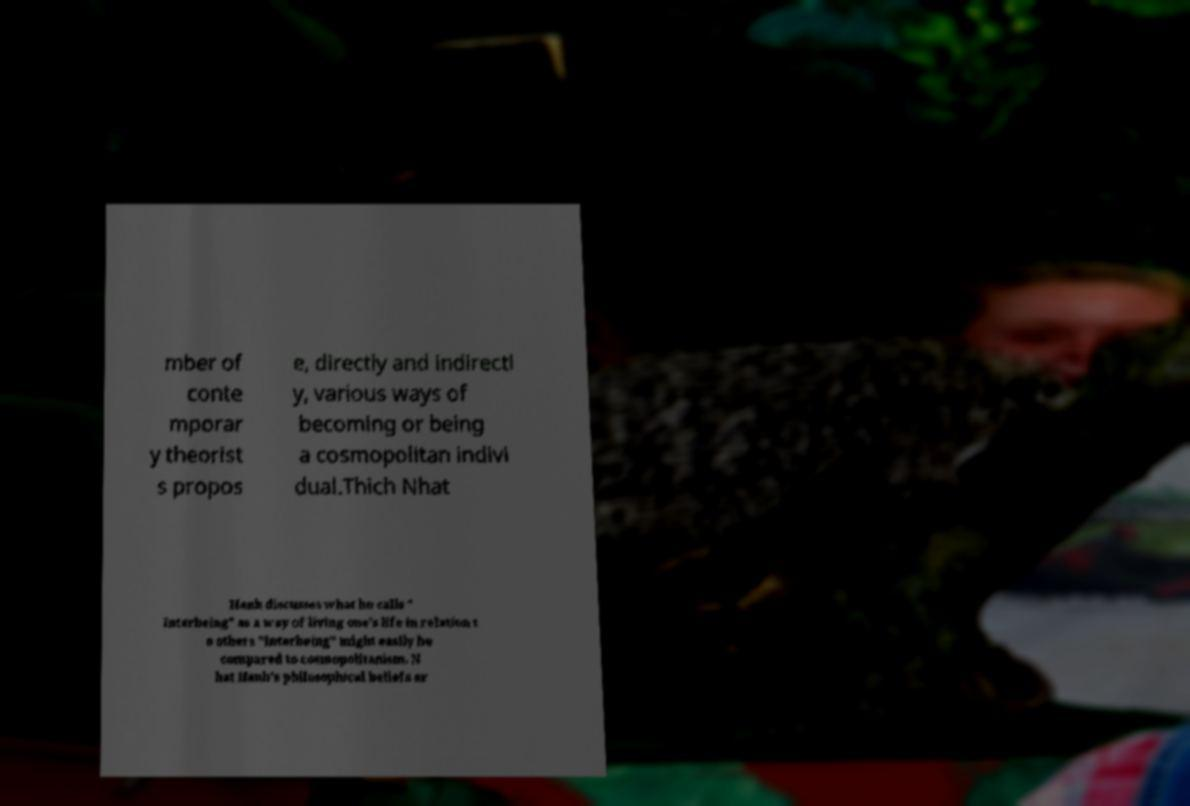Could you assist in decoding the text presented in this image and type it out clearly? mber of conte mporar y theorist s propos e, directly and indirectl y, various ways of becoming or being a cosmopolitan indivi dual.Thich Nhat Hanh discusses what he calls " Interbeing" as a way of living one's life in relation t o others "Interbeing" might easily be compared to cosmopolitanism. N hat Hanh's philosophical beliefs ar 